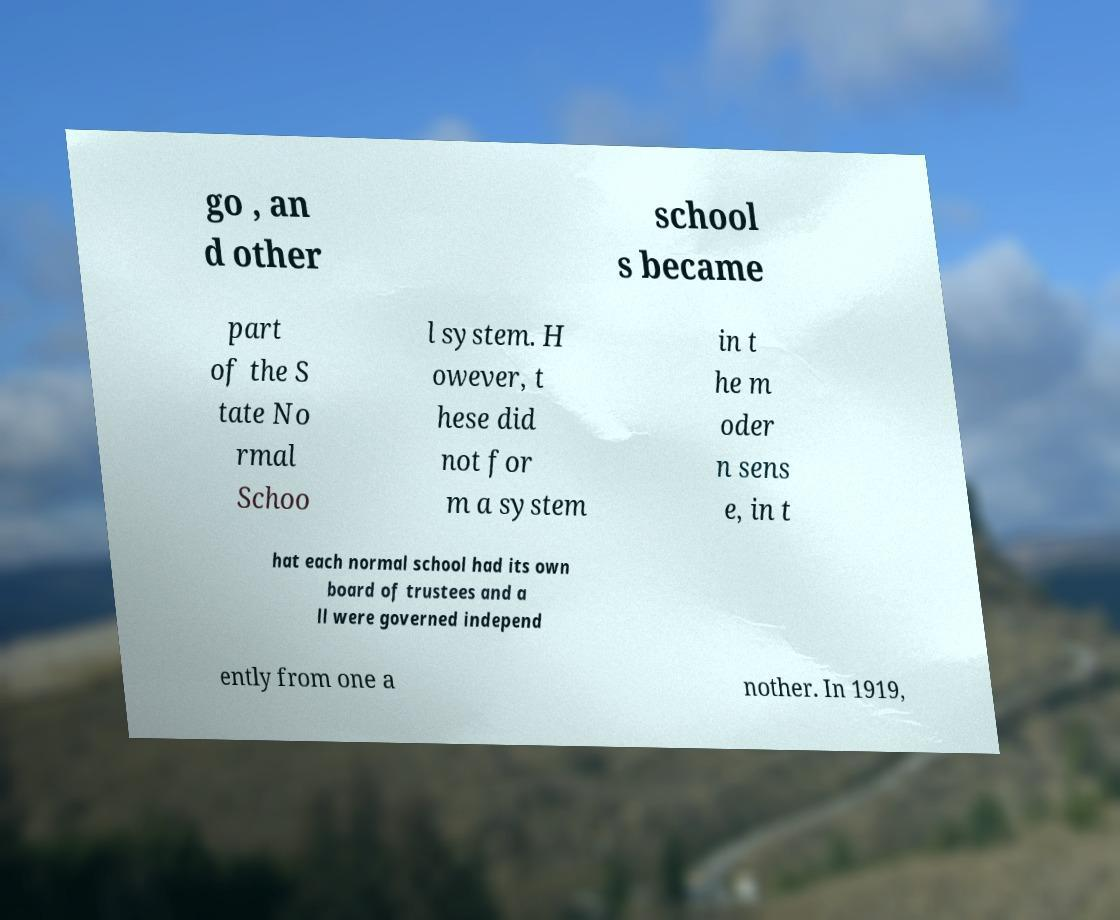Please read and relay the text visible in this image. What does it say? go , an d other school s became part of the S tate No rmal Schoo l system. H owever, t hese did not for m a system in t he m oder n sens e, in t hat each normal school had its own board of trustees and a ll were governed independ ently from one a nother. In 1919, 